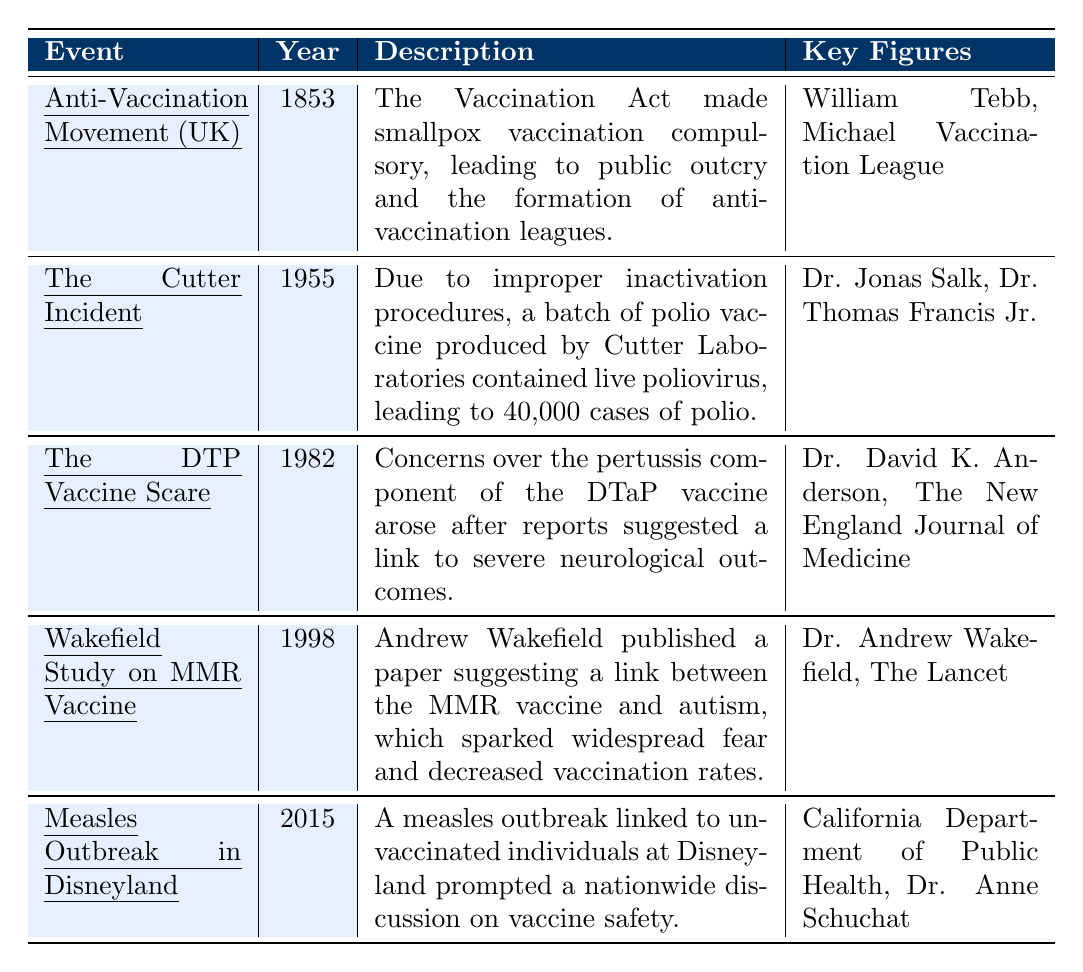What year did the Anti-Vaccination Movement in the UK start? The table indicates that the Anti-Vaccination Movement in the UK began in 1853.
Answer: 1853 Which event is associated with a significant measles outbreak? The table lists the Measles Outbreak in Disneyland in 2015 as an event linked to a measles outbreak.
Answer: Measles Outbreak in Disneyland Who were key figures in the Cutter Incident? According to the table, the key figures involved in the Cutter Incident were Dr. Jonas Salk and Dr. Thomas Francis Jr.
Answer: Dr. Jonas Salk, Dr. Thomas Francis Jr What sparked skepticism toward vaccines in the 1982 DTP Vaccine Scare? The DTP Vaccine Scare arose due to concerns over the pertussis component of the DTaP vaccine, linked to severe neurological outcomes.
Answer: Concerns about neurological outcomes Which event highlighted a link between a vaccine and autism? The Wakefield Study on the MMR vaccine published in 1998 suggested a link between the MMR vaccine and autism.
Answer: Wakefield Study on MMR Vaccine Was the Cutter Incident associated with a significant increase in polio cases? Yes, the table states that the Cutter Incident led to 40,000 cases of polio, indicating a significant increase.
Answer: Yes Identify the earliest event in the table related to vaccination hesitancy. The earliest event listed is the Anti-Vaccination Movement in the UK in 1853.
Answer: Anti-Vaccination Movement in the UK List all events from the table that occurred after 1980. The events that occurred after 1980 are the DTP Vaccine Scare in 1982, the Wakefield Study in 1998, and the Measles Outbreak in Disneyland in 2015.
Answer: DTP Vaccine Scare, Wakefield Study, Measles Outbreak Which event had the involvement of The Lancet? The Wakefield Study on the MMR vaccine involved The Lancet according to the table.
Answer: Wakefield Study on MMR Vaccine In which event was public confidence in vaccination programs notably affected? The DTP Vaccine Scare in 1982 affected public confidence in vaccination programs due to reported concerns.
Answer: The DTP Vaccine Scare Calculate how many years separated the Anti-Vaccination Movement and the Cutter Incident. The Anti-Vaccination Movement occurred in 1853 and the Cutter Incident in 1955. The difference is 1955 - 1853 = 102 years.
Answer: 102 years 